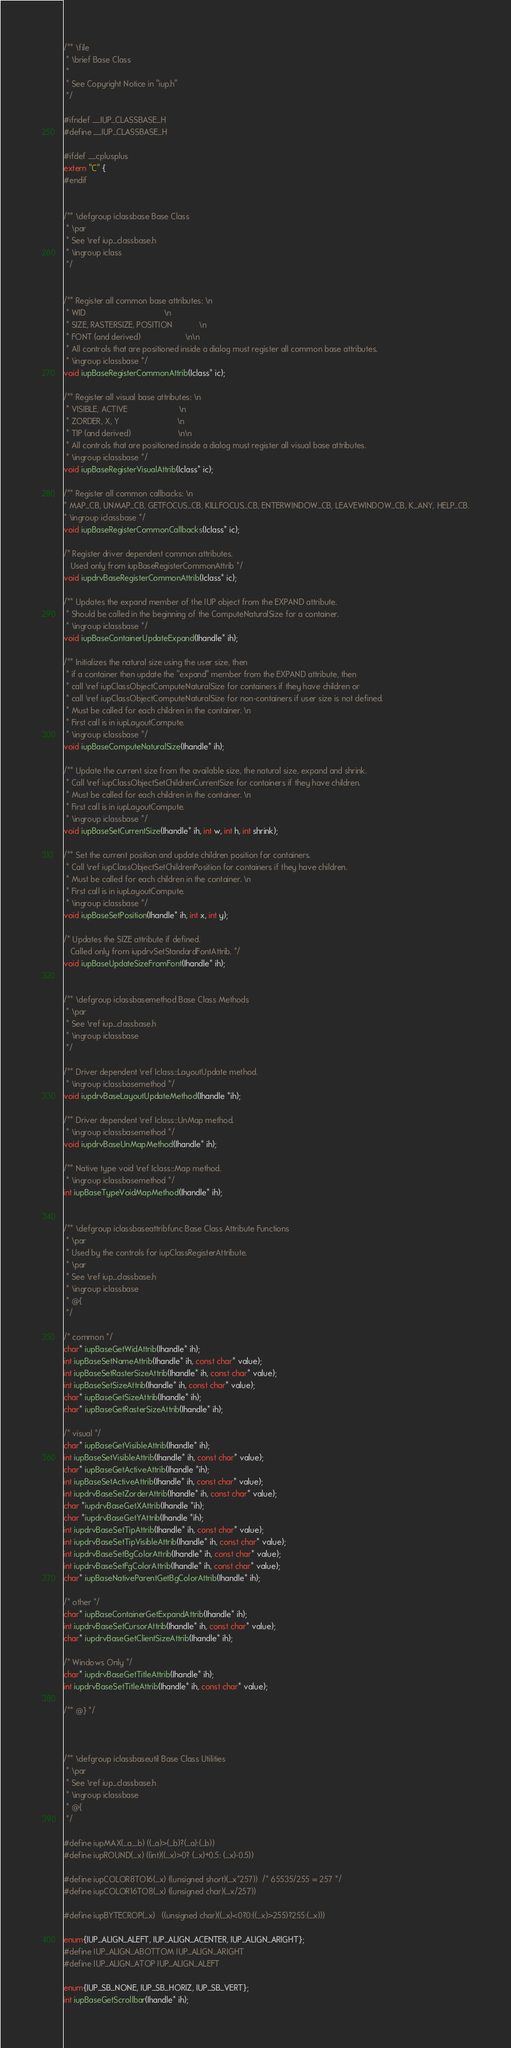Convert code to text. <code><loc_0><loc_0><loc_500><loc_500><_C_>/** \file
 * \brief Base Class
 *
 * See Copyright Notice in "iup.h"
 */
 
#ifndef __IUP_CLASSBASE_H 
#define __IUP_CLASSBASE_H

#ifdef __cplusplus
extern "C" {
#endif


/** \defgroup iclassbase Base Class
 * \par
 * See \ref iup_classbase.h
 * \ingroup iclass
 */


/** Register all common base attributes: \n
 * WID                                   \n
 * SIZE, RASTERSIZE, POSITION            \n
 * FONT (and derived)                    \n\n
 * All controls that are positioned inside a dialog must register all common base attributes.
 * \ingroup iclassbase */
void iupBaseRegisterCommonAttrib(Iclass* ic);

/** Register all visual base attributes: \n
 * VISIBLE, ACTIVE                       \n
 * ZORDER, X, Y                          \n
 * TIP (and derived)                     \n\n
 * All controls that are positioned inside a dialog must register all visual base attributes.
 * \ingroup iclassbase */
void iupBaseRegisterVisualAttrib(Iclass* ic);

/** Register all common callbacks: \n
* MAP_CB, UNMAP_CB, GETFOCUS_CB, KILLFOCUS_CB, ENTERWINDOW_CB, LEAVEWINDOW_CB, K_ANY, HELP_CB.
* \ingroup iclassbase */
void iupBaseRegisterCommonCallbacks(Iclass* ic);

/* Register driver dependent common attributes. 
   Used only from iupBaseRegisterCommonAttrib */
void iupdrvBaseRegisterCommonAttrib(Iclass* ic);

/** Updates the expand member of the IUP object from the EXPAND attribute.
 * Should be called in the beginning of the ComputeNaturalSize for a container.
 * \ingroup iclassbase */
void iupBaseContainerUpdateExpand(Ihandle* ih);

/** Initializes the natural size using the user size, then
 * if a container then update the "expand" member from the EXPAND attribute, then
 * call \ref iupClassObjectComputeNaturalSize for containers if they have children or
 * call \ref iupClassObjectComputeNaturalSize for non-containers if user size is not defined.
 * Must be called for each children in the container. \n
 * First call is in iupLayoutCompute.
 * \ingroup iclassbase */
void iupBaseComputeNaturalSize(Ihandle* ih);

/** Update the current size from the available size, the natural size, expand and shrink.
 * Call \ref iupClassObjectSetChildrenCurrentSize for containers if they have children.
 * Must be called for each children in the container. \n
 * First call is in iupLayoutCompute.
 * \ingroup iclassbase */
void iupBaseSetCurrentSize(Ihandle* ih, int w, int h, int shrink);

/** Set the current position and update children position for containers.
 * Call \ref iupClassObjectSetChildrenPosition for containers if they have children.
 * Must be called for each children in the container. \n
 * First call is in iupLayoutCompute.
 * \ingroup iclassbase */
void iupBaseSetPosition(Ihandle* ih, int x, int y);

/* Updates the SIZE attribute if defined. 
   Called only from iupdrvSetStandardFontAttrib. */
void iupBaseUpdateSizeFromFont(Ihandle* ih);


/** \defgroup iclassbasemethod Base Class Methods
 * \par
 * See \ref iup_classbase.h
 * \ingroup iclassbase
 */

/** Driver dependent \ref Iclass::LayoutUpdate method.
 * \ingroup iclassbasemethod */
void iupdrvBaseLayoutUpdateMethod(Ihandle *ih);

/** Driver dependent \ref Iclass::UnMap method.
 * \ingroup iclassbasemethod */
void iupdrvBaseUnMapMethod(Ihandle* ih);

/** Native type void \ref Iclass::Map method.
 * \ingroup iclassbasemethod */
int iupBaseTypeVoidMapMethod(Ihandle* ih);


/** \defgroup iclassbaseattribfunc Base Class Attribute Functions
 * \par
 * Used by the controls for iupClassRegisterAttribute. 
 * \par
 * See \ref iup_classbase.h
 * \ingroup iclassbase
 * @{
 */

/* common */
char* iupBaseGetWidAttrib(Ihandle* ih);
int iupBaseSetNameAttrib(Ihandle* ih, const char* value);
int iupBaseSetRasterSizeAttrib(Ihandle* ih, const char* value);
int iupBaseSetSizeAttrib(Ihandle* ih, const char* value);
char* iupBaseGetSizeAttrib(Ihandle* ih);
char* iupBaseGetRasterSizeAttrib(Ihandle* ih);

/* visual */
char* iupBaseGetVisibleAttrib(Ihandle* ih);
int iupBaseSetVisibleAttrib(Ihandle* ih, const char* value);
char* iupBaseGetActiveAttrib(Ihandle *ih);
int iupBaseSetActiveAttrib(Ihandle* ih, const char* value);
int iupdrvBaseSetZorderAttrib(Ihandle* ih, const char* value);
char *iupdrvBaseGetXAttrib(Ihandle *ih);
char *iupdrvBaseGetYAttrib(Ihandle *ih);
int iupdrvBaseSetTipAttrib(Ihandle* ih, const char* value);
int iupdrvBaseSetTipVisibleAttrib(Ihandle* ih, const char* value);
int iupdrvBaseSetBgColorAttrib(Ihandle* ih, const char* value);
int iupdrvBaseSetFgColorAttrib(Ihandle* ih, const char* value);
char* iupBaseNativeParentGetBgColorAttrib(Ihandle* ih);

/* other */
char* iupBaseContainerGetExpandAttrib(Ihandle* ih);
int iupdrvBaseSetCursorAttrib(Ihandle* ih, const char* value);
char* iupdrvBaseGetClientSizeAttrib(Ihandle* ih);

/* Windows Only */
char* iupdrvBaseGetTitleAttrib(Ihandle* ih);
int iupdrvBaseSetTitleAttrib(Ihandle* ih, const char* value);

/** @} */



/** \defgroup iclassbaseutil Base Class Utilities
 * \par
 * See \ref iup_classbase.h
 * \ingroup iclassbase
 * @{
 */

#define iupMAX(_a,_b) ((_a)>(_b)?(_a):(_b))
#define iupROUND(_x) ((int)((_x)>0? (_x)+0.5: (_x)-0.5))

#define iupCOLOR8TO16(_x) ((unsigned short)(_x*257))  /* 65535/255 = 257 */
#define iupCOLOR16TO8(_x) ((unsigned char)(_x/257))

#define iupBYTECROP(_x)   ((unsigned char)((_x)<0?0:((_x)>255)?255:(_x)))

enum{IUP_ALIGN_ALEFT, IUP_ALIGN_ACENTER, IUP_ALIGN_ARIGHT};
#define IUP_ALIGN_ABOTTOM IUP_ALIGN_ARIGHT
#define IUP_ALIGN_ATOP IUP_ALIGN_ALEFT

enum{IUP_SB_NONE, IUP_SB_HORIZ, IUP_SB_VERT};
int iupBaseGetScrollbar(Ihandle* ih);
</code> 